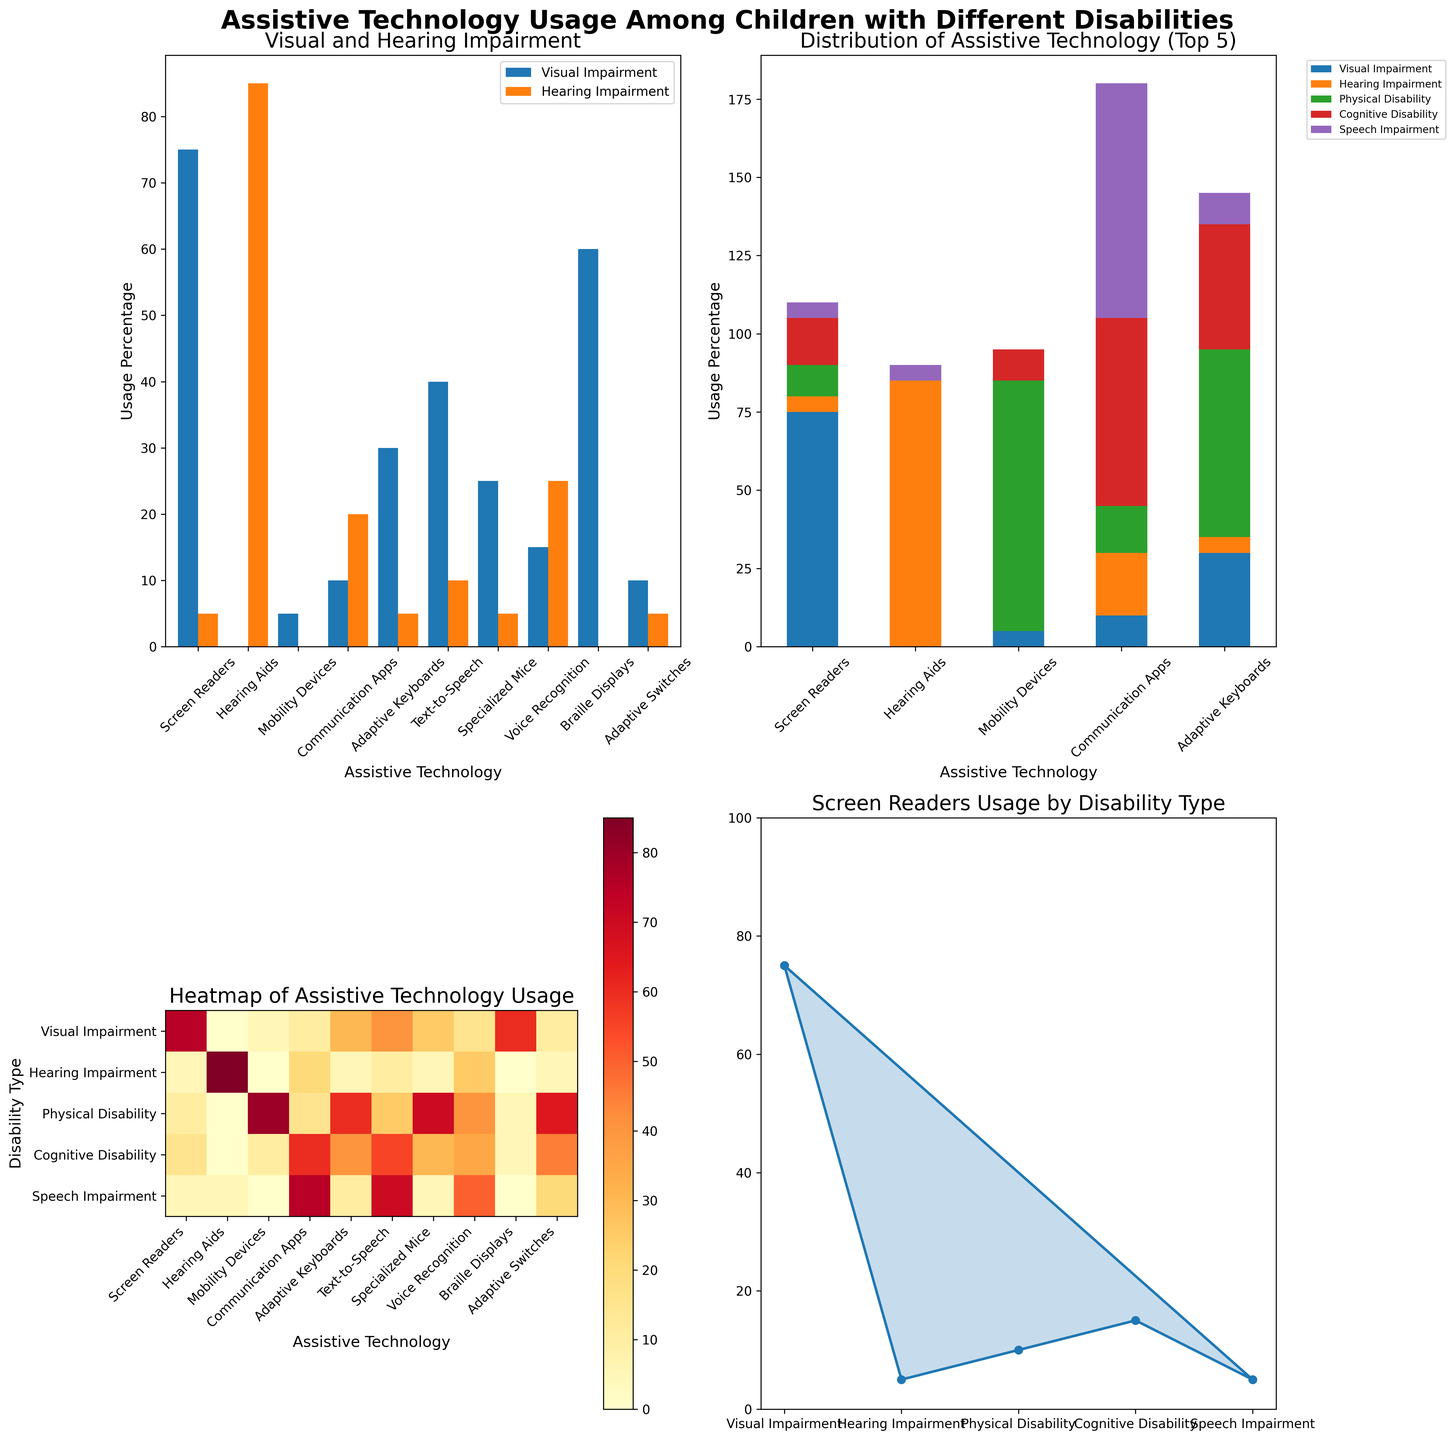What two types of impairment are compared in the bar chart? The title of the bar chart in the top left subplot is "Visual and Hearing Impairment." This indicates that the chart compares the usage percentages of assistive technologies between visual and hearing impairments.
Answer: Visual and Hearing Impairment Which disability type has the highest usage percentage for screen readers? The radar chart in the bottom right subplot focuses on screen reader usage. The 'Visual Impairment' data point is the highest at around 75%.
Answer: Visual Impairment What are the top 5 assistive technologies shown in the stacked bar chart? The title of the stacked bar chart in the top right subplot mentions "Top 5." Inspecting the x-axis shows the top 5 technologies are Screen Readers, Hearing Aids, Mobility Devices, Communication Apps, and Adaptive Keyboards.
Answer: Screen Readers, Hearing Aids, Mobility Devices, Communication Apps, Adaptive Keyboards Which assistive technology shows the most usage variability across different disabilities in the heatmap? By looking at the heatmap in the bottom left subplot, we notice that Screen Readers, Communication Apps, and Adaptive Keyboards show large variability. However, Communication Apps vary from 10% to 75%, indicating the highest variability.
Answer: Communication Apps How does the usage of adaptive keyboards compare between physical disability and speech impairment? The heatmap reveals the exact usage percentages. For 'Physical Disability,' adaptive keyboards have 60% usage, whereas for 'Speech Impairment,' it's 10%. Comparing these numbers shows that usage is higher for physical disability.
Answer: Higher for Physical Disability Which disability type has the lowest usage for hearing aids? By observing the values in the bar chart (top left) and cross-referencing with the heatmap (bottom left), we see that 'Visual Impairment,' 'Physical Disability,' and 'Cognitive Disability' have 0% usage, but the lowest is still considered to be 'Visual Impairment' as it comes first.
Answer: Visual Impairment What is the average percentage usage of text-to-speech technology across all disabilities? To find this, sum the text-to-speech usage values from the heatmap or data: 40%, 10%, 25%, 55%, 70%. The total is 200%. Dividing by the number of disabilities (5) gives us 40%.
Answer: 40% What is the total usage percentage of specialized mice across all disabilities shown in the bar chart and heatmap? Sum the percentages for specialized mice from both the heatmap and data: 25%, 5%, 70%, 30%, 5%. The total is 135%.
Answer: 135% Which assistive technology shows no usage for visual impairment? By carefully checking the data matrix and cross-referencing with both the bar chart and heatmap, it's clear that Hearing Aids (0%) and Braille Displays (0%) show no usage for visual impairment.
Answer: Hearing Aids and Braille Displays 